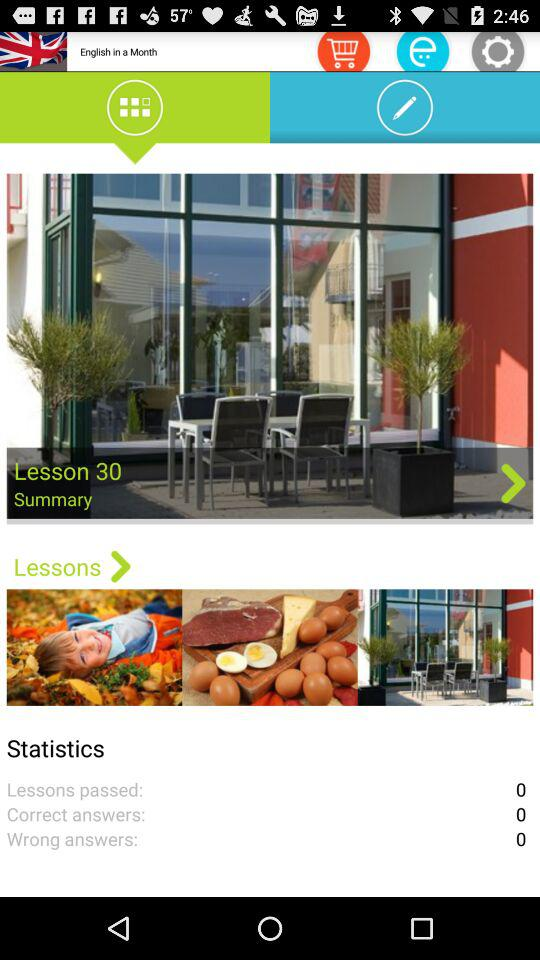What is the lesson number? The lesson number is 30. 